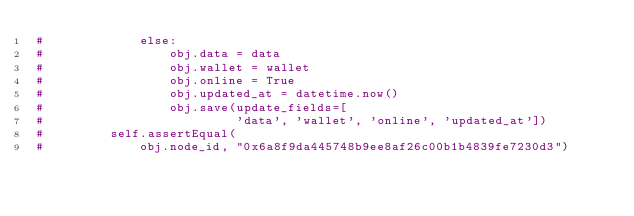Convert code to text. <code><loc_0><loc_0><loc_500><loc_500><_Python_>#             else:
#                 obj.data = data
#                 obj.wallet = wallet
#                 obj.online = True
#                 obj.updated_at = datetime.now()
#                 obj.save(update_fields=[
#                          'data', 'wallet', 'online', 'updated_at'])
#         self.assertEqual(
#             obj.node_id, "0x6a8f9da445748b9ee8af26c00b1b4839fe7230d3")
</code> 